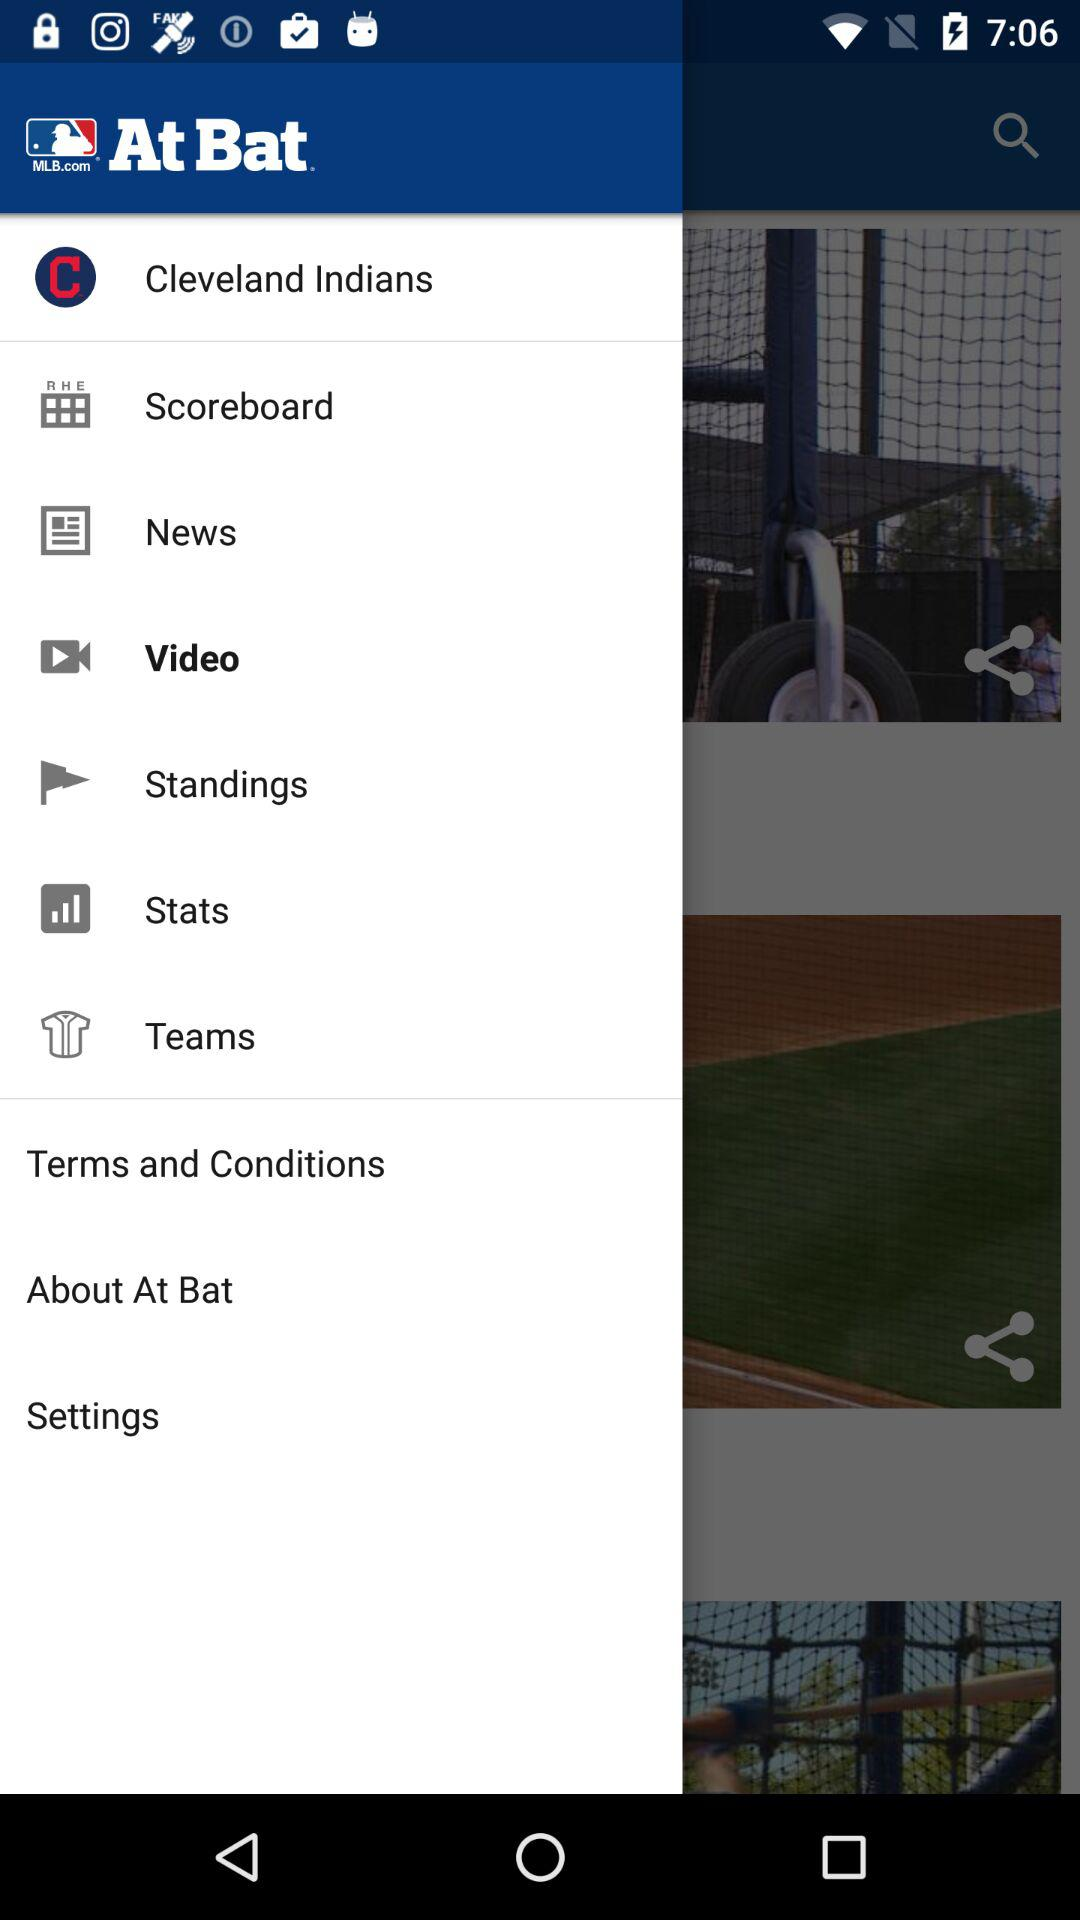What is the selected item? The selected item is "Video". 